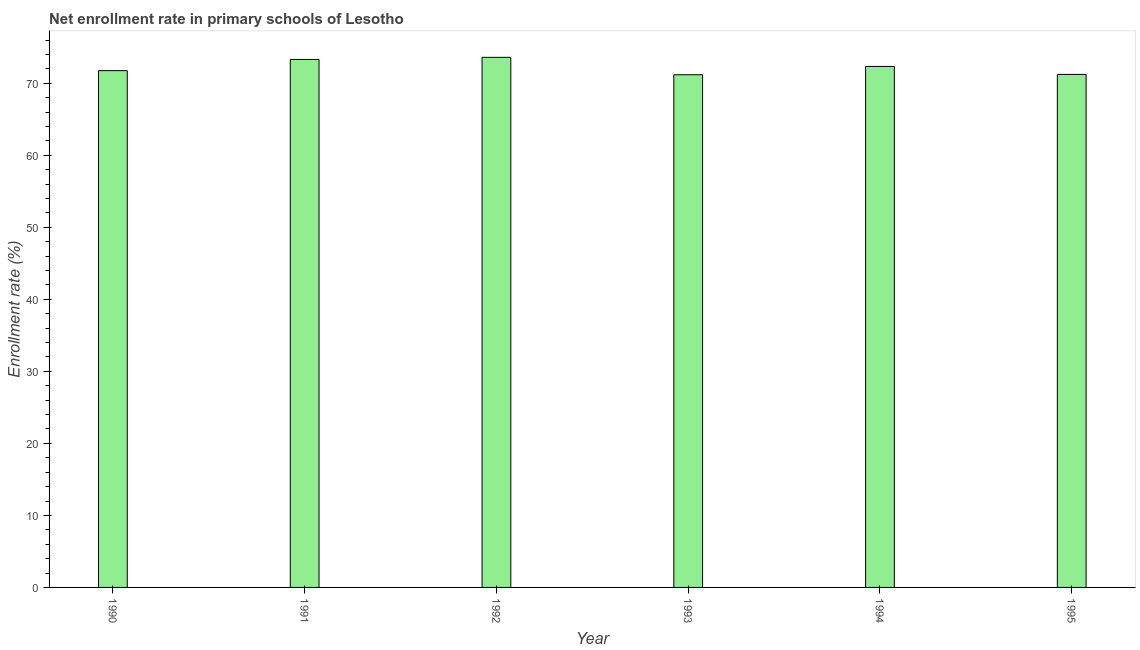What is the title of the graph?
Your answer should be compact. Net enrollment rate in primary schools of Lesotho. What is the label or title of the Y-axis?
Offer a terse response. Enrollment rate (%). What is the net enrollment rate in primary schools in 1992?
Make the answer very short. 73.61. Across all years, what is the maximum net enrollment rate in primary schools?
Your answer should be very brief. 73.61. Across all years, what is the minimum net enrollment rate in primary schools?
Give a very brief answer. 71.19. In which year was the net enrollment rate in primary schools minimum?
Your answer should be very brief. 1993. What is the sum of the net enrollment rate in primary schools?
Your answer should be very brief. 433.44. What is the difference between the net enrollment rate in primary schools in 1990 and 1994?
Ensure brevity in your answer.  -0.58. What is the average net enrollment rate in primary schools per year?
Provide a short and direct response. 72.24. What is the median net enrollment rate in primary schools?
Provide a succinct answer. 72.05. In how many years, is the net enrollment rate in primary schools greater than 34 %?
Offer a terse response. 6. Is the difference between the net enrollment rate in primary schools in 1990 and 1995 greater than the difference between any two years?
Offer a terse response. No. What is the difference between the highest and the second highest net enrollment rate in primary schools?
Provide a succinct answer. 0.29. What is the difference between the highest and the lowest net enrollment rate in primary schools?
Make the answer very short. 2.42. In how many years, is the net enrollment rate in primary schools greater than the average net enrollment rate in primary schools taken over all years?
Your answer should be very brief. 3. How many bars are there?
Provide a succinct answer. 6. How many years are there in the graph?
Provide a succinct answer. 6. What is the Enrollment rate (%) of 1990?
Give a very brief answer. 71.76. What is the Enrollment rate (%) in 1991?
Make the answer very short. 73.31. What is the Enrollment rate (%) of 1992?
Offer a terse response. 73.61. What is the Enrollment rate (%) in 1993?
Your answer should be very brief. 71.19. What is the Enrollment rate (%) of 1994?
Make the answer very short. 72.34. What is the Enrollment rate (%) of 1995?
Keep it short and to the point. 71.23. What is the difference between the Enrollment rate (%) in 1990 and 1991?
Your response must be concise. -1.55. What is the difference between the Enrollment rate (%) in 1990 and 1992?
Make the answer very short. -1.85. What is the difference between the Enrollment rate (%) in 1990 and 1993?
Offer a terse response. 0.57. What is the difference between the Enrollment rate (%) in 1990 and 1994?
Your answer should be very brief. -0.58. What is the difference between the Enrollment rate (%) in 1990 and 1995?
Provide a succinct answer. 0.53. What is the difference between the Enrollment rate (%) in 1991 and 1992?
Make the answer very short. -0.29. What is the difference between the Enrollment rate (%) in 1991 and 1993?
Ensure brevity in your answer.  2.12. What is the difference between the Enrollment rate (%) in 1991 and 1994?
Your answer should be compact. 0.97. What is the difference between the Enrollment rate (%) in 1991 and 1995?
Give a very brief answer. 2.08. What is the difference between the Enrollment rate (%) in 1992 and 1993?
Offer a terse response. 2.42. What is the difference between the Enrollment rate (%) in 1992 and 1994?
Your answer should be compact. 1.27. What is the difference between the Enrollment rate (%) in 1992 and 1995?
Offer a very short reply. 2.37. What is the difference between the Enrollment rate (%) in 1993 and 1994?
Your response must be concise. -1.15. What is the difference between the Enrollment rate (%) in 1993 and 1995?
Give a very brief answer. -0.04. What is the difference between the Enrollment rate (%) in 1994 and 1995?
Offer a terse response. 1.11. What is the ratio of the Enrollment rate (%) in 1990 to that in 1992?
Provide a succinct answer. 0.97. What is the ratio of the Enrollment rate (%) in 1990 to that in 1993?
Give a very brief answer. 1.01. What is the ratio of the Enrollment rate (%) in 1990 to that in 1994?
Provide a short and direct response. 0.99. What is the ratio of the Enrollment rate (%) in 1991 to that in 1992?
Ensure brevity in your answer.  1. What is the ratio of the Enrollment rate (%) in 1991 to that in 1993?
Offer a very short reply. 1.03. What is the ratio of the Enrollment rate (%) in 1991 to that in 1994?
Your answer should be compact. 1.01. What is the ratio of the Enrollment rate (%) in 1991 to that in 1995?
Make the answer very short. 1.03. What is the ratio of the Enrollment rate (%) in 1992 to that in 1993?
Make the answer very short. 1.03. What is the ratio of the Enrollment rate (%) in 1992 to that in 1995?
Offer a terse response. 1.03. 